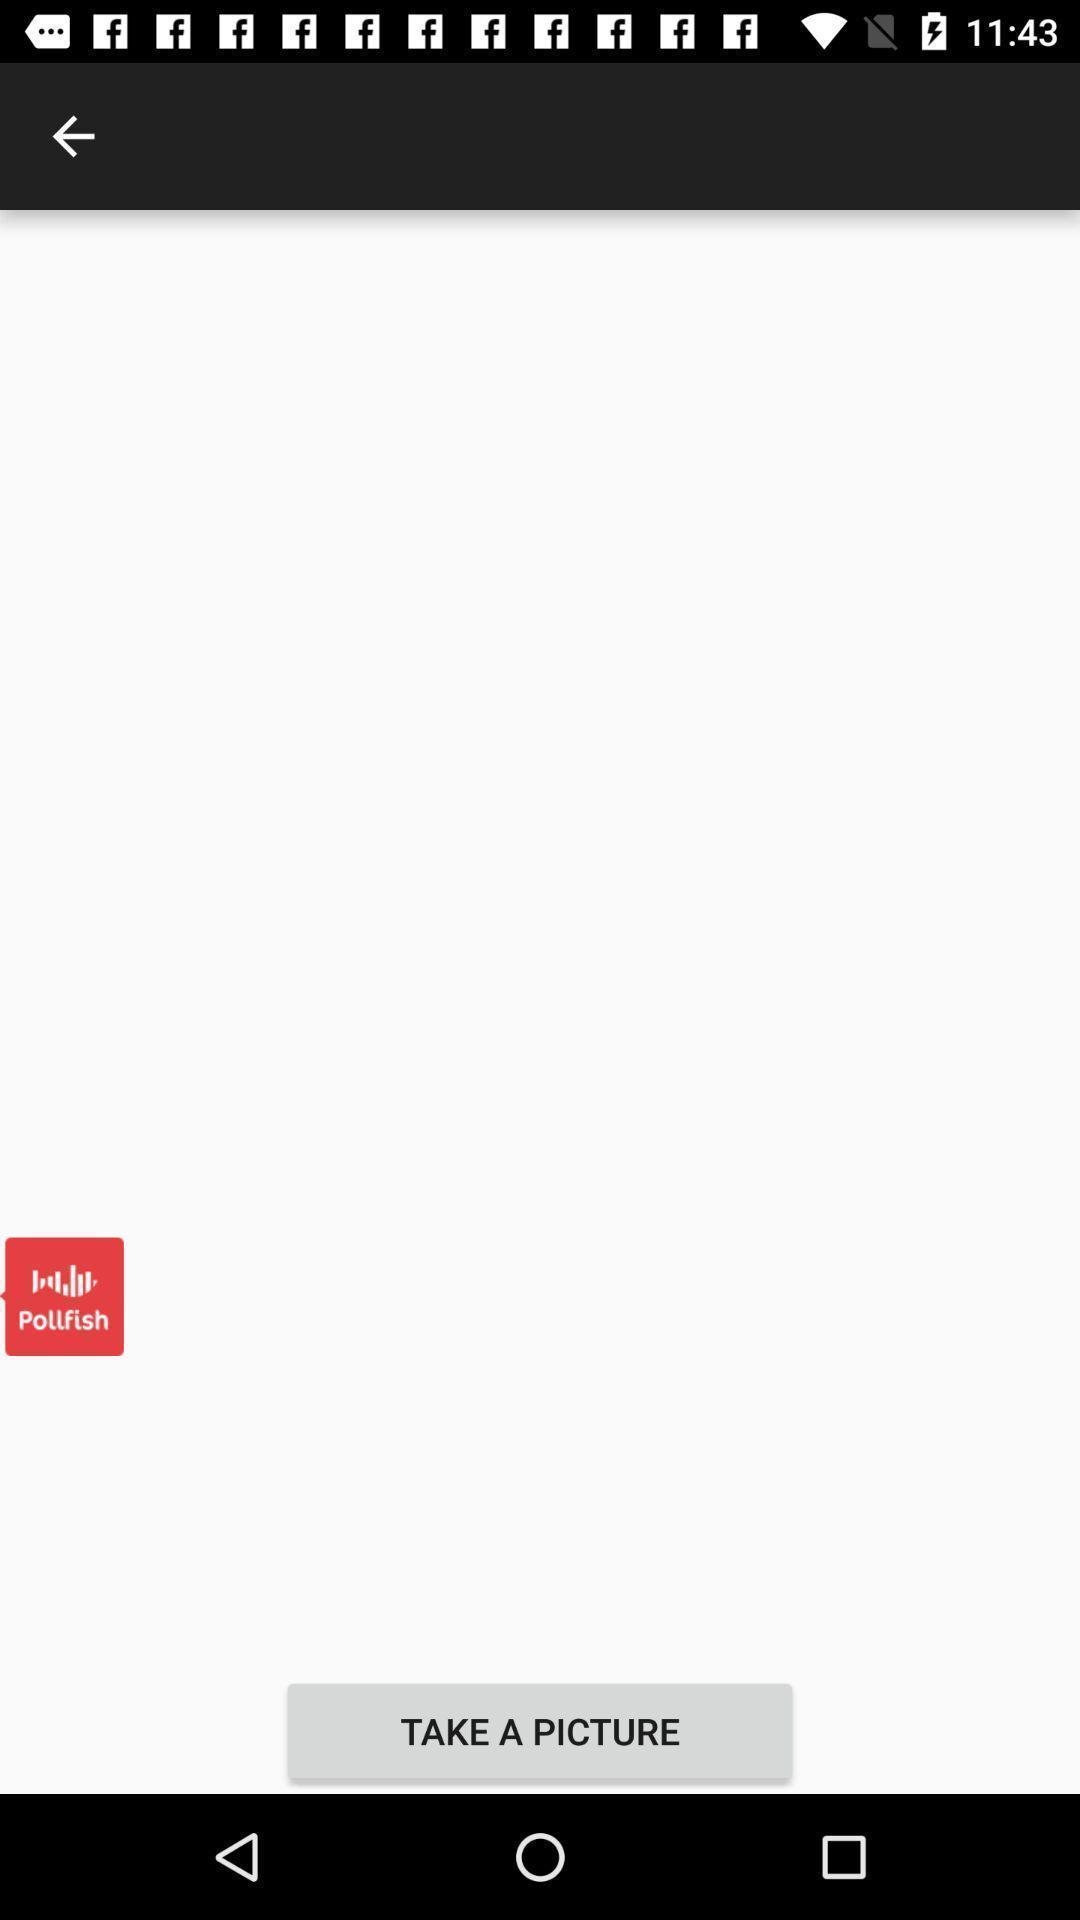Explain what's happening in this screen capture. Page displaying to take the picture. 